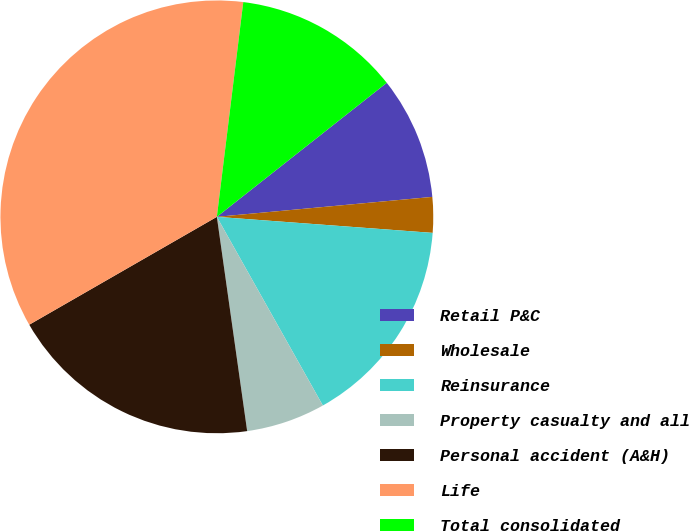Convert chart to OTSL. <chart><loc_0><loc_0><loc_500><loc_500><pie_chart><fcel>Retail P&C<fcel>Wholesale<fcel>Reinsurance<fcel>Property casualty and all<fcel>Personal accident (A&H)<fcel>Life<fcel>Total consolidated<nl><fcel>9.16%<fcel>2.65%<fcel>15.67%<fcel>5.91%<fcel>18.93%<fcel>35.25%<fcel>12.42%<nl></chart> 